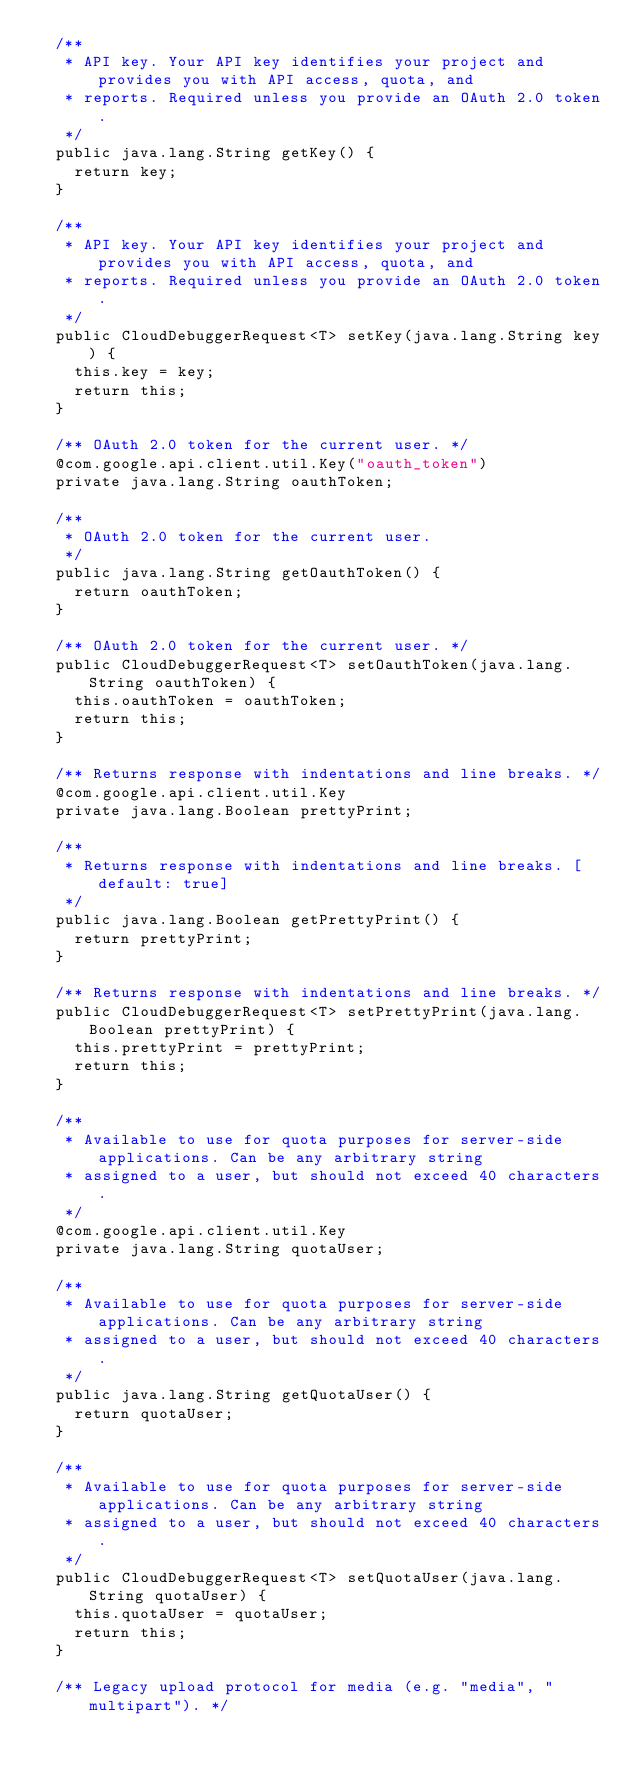Convert code to text. <code><loc_0><loc_0><loc_500><loc_500><_Java_>  /**
   * API key. Your API key identifies your project and provides you with API access, quota, and
   * reports. Required unless you provide an OAuth 2.0 token.
   */
  public java.lang.String getKey() {
    return key;
  }

  /**
   * API key. Your API key identifies your project and provides you with API access, quota, and
   * reports. Required unless you provide an OAuth 2.0 token.
   */
  public CloudDebuggerRequest<T> setKey(java.lang.String key) {
    this.key = key;
    return this;
  }

  /** OAuth 2.0 token for the current user. */
  @com.google.api.client.util.Key("oauth_token")
  private java.lang.String oauthToken;

  /**
   * OAuth 2.0 token for the current user.
   */
  public java.lang.String getOauthToken() {
    return oauthToken;
  }

  /** OAuth 2.0 token for the current user. */
  public CloudDebuggerRequest<T> setOauthToken(java.lang.String oauthToken) {
    this.oauthToken = oauthToken;
    return this;
  }

  /** Returns response with indentations and line breaks. */
  @com.google.api.client.util.Key
  private java.lang.Boolean prettyPrint;

  /**
   * Returns response with indentations and line breaks. [default: true]
   */
  public java.lang.Boolean getPrettyPrint() {
    return prettyPrint;
  }

  /** Returns response with indentations and line breaks. */
  public CloudDebuggerRequest<T> setPrettyPrint(java.lang.Boolean prettyPrint) {
    this.prettyPrint = prettyPrint;
    return this;
  }

  /**
   * Available to use for quota purposes for server-side applications. Can be any arbitrary string
   * assigned to a user, but should not exceed 40 characters.
   */
  @com.google.api.client.util.Key
  private java.lang.String quotaUser;

  /**
   * Available to use for quota purposes for server-side applications. Can be any arbitrary string
   * assigned to a user, but should not exceed 40 characters.
   */
  public java.lang.String getQuotaUser() {
    return quotaUser;
  }

  /**
   * Available to use for quota purposes for server-side applications. Can be any arbitrary string
   * assigned to a user, but should not exceed 40 characters.
   */
  public CloudDebuggerRequest<T> setQuotaUser(java.lang.String quotaUser) {
    this.quotaUser = quotaUser;
    return this;
  }

  /** Legacy upload protocol for media (e.g. "media", "multipart"). */</code> 